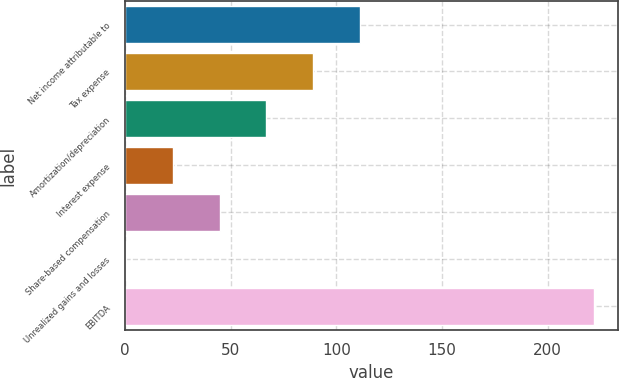Convert chart. <chart><loc_0><loc_0><loc_500><loc_500><bar_chart><fcel>Net income attributable to<fcel>Tax expense<fcel>Amortization/depreciation<fcel>Interest expense<fcel>Share-based compensation<fcel>Unrealized gains and losses<fcel>EBITDA<nl><fcel>111.2<fcel>89.02<fcel>66.84<fcel>22.48<fcel>44.66<fcel>0.3<fcel>222.1<nl></chart> 